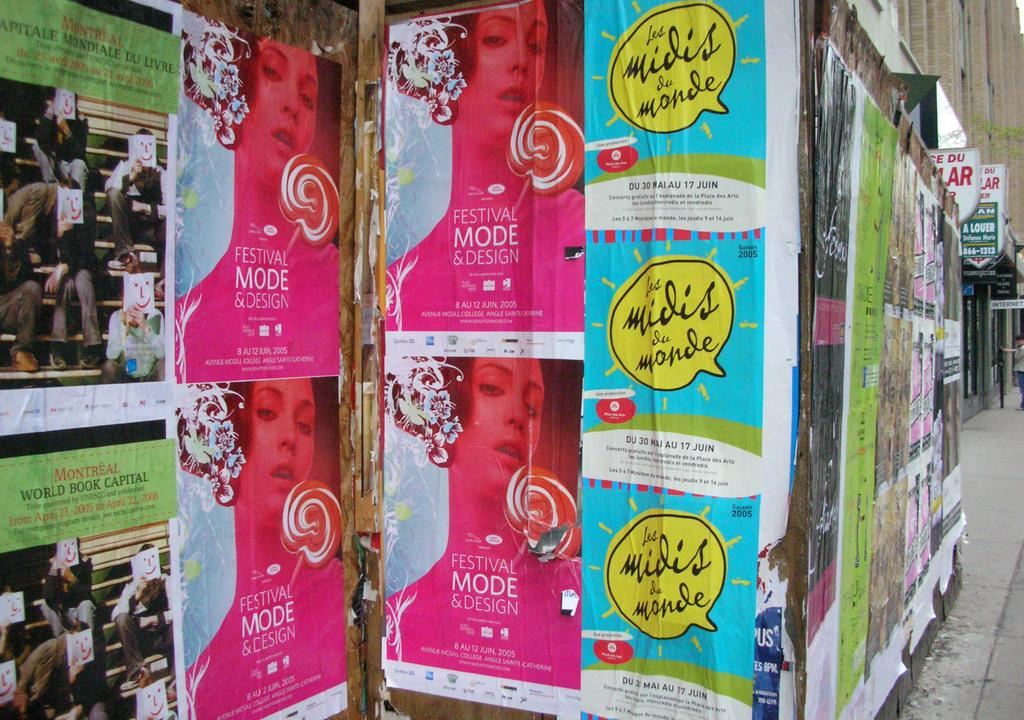<image>
Offer a succinct explanation of the picture presented. A wall covered in posters, one of which is advertising Festival Mode and Design. 